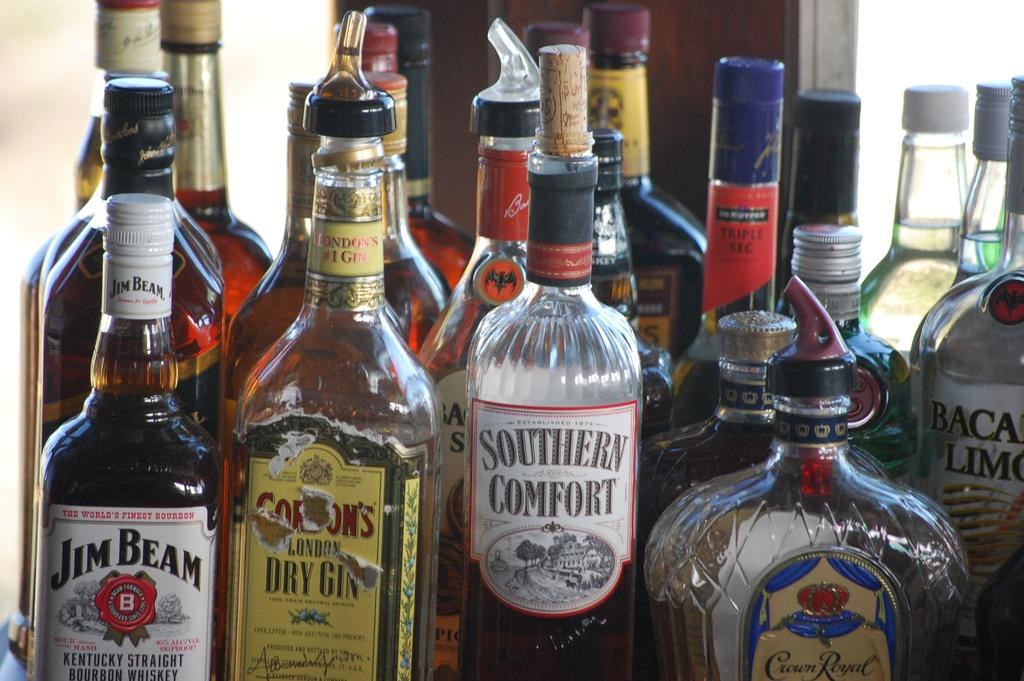<image>
Present a compact description of the photo's key features. Half empty bottle of Southern Comfort in front of some other bottles. 